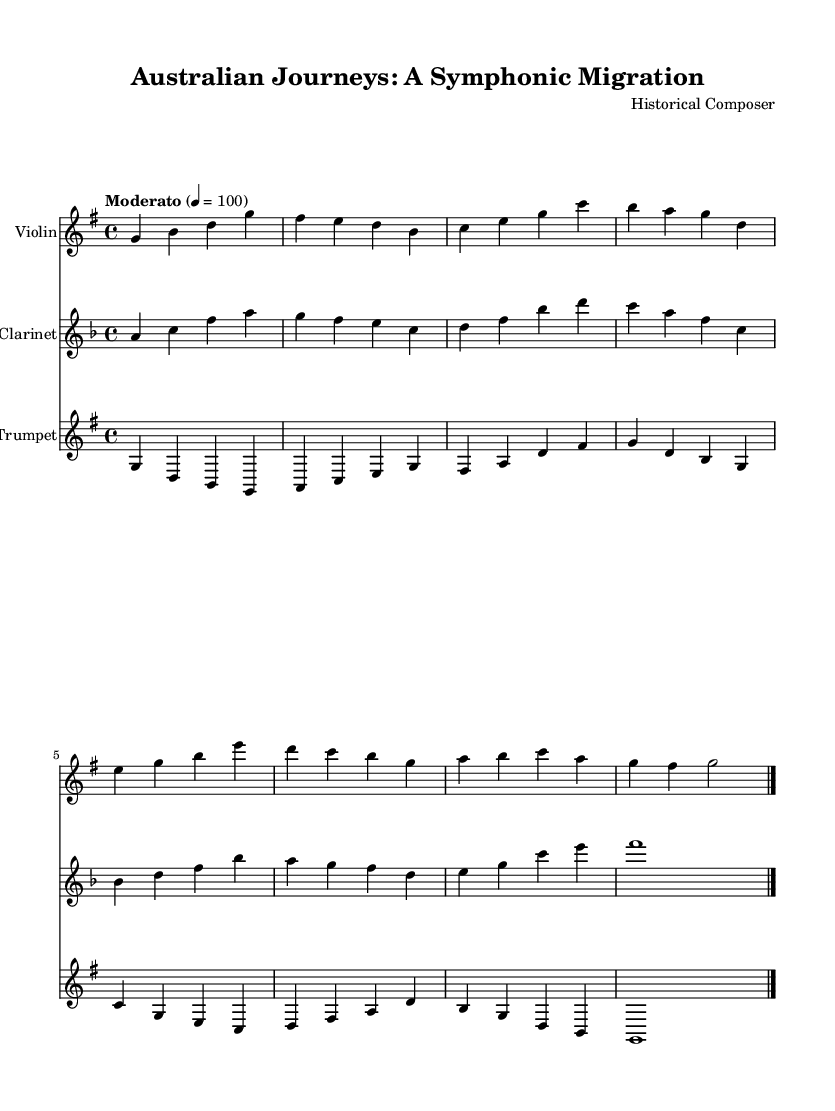What is the key signature of this music? The key signature is identified by looking at the key symbol placed at the beginning of the staff, which shows that there is one sharp. This corresponds to G major.
Answer: G major What is the time signature of this piece? The time signature determines the number of beats in each measure. Here, the 4/4 indicates there are four beats per measure, which is indicated at the beginning of the score.
Answer: 4/4 What is the tempo marking of this symphony? The tempo marking is stated at the beginning with the word marking "Moderato" followed by the tempo indication of 100 beats per minute.
Answer: Moderato How many measures are there in the Violin part? To determine the number of measures, I count the segments separated by vertical lines (bar lines) in the Violin staff. There are a total of eight measures.
Answer: Eight What is the highest note played by the Trumpet? Looking at the Trumpet part, the highest note can be found by examining the notes corresponding to the staff lines and spaces. The highest note is A, which appears at the beginning of one of the measures.
Answer: A Which instrument plays the Ocean Voyage section? By reviewing the score, I can see that the Clarinet part is labeled as "Ocean Voyage," indicating that this is the section dedicated to that instrument.
Answer: Clarinet How do the themes in the Ocean Voyage differ from the Departure theme? The themes can be analyzed by their melodic contours, rhythms, and dynamics. The Ocean Voyage section has a more flowing rhythm and broader melodic range, signifying the vastness of the ocean as compared to the more structured and rhythmic first theme of departure.
Answer: Oceanic flow 